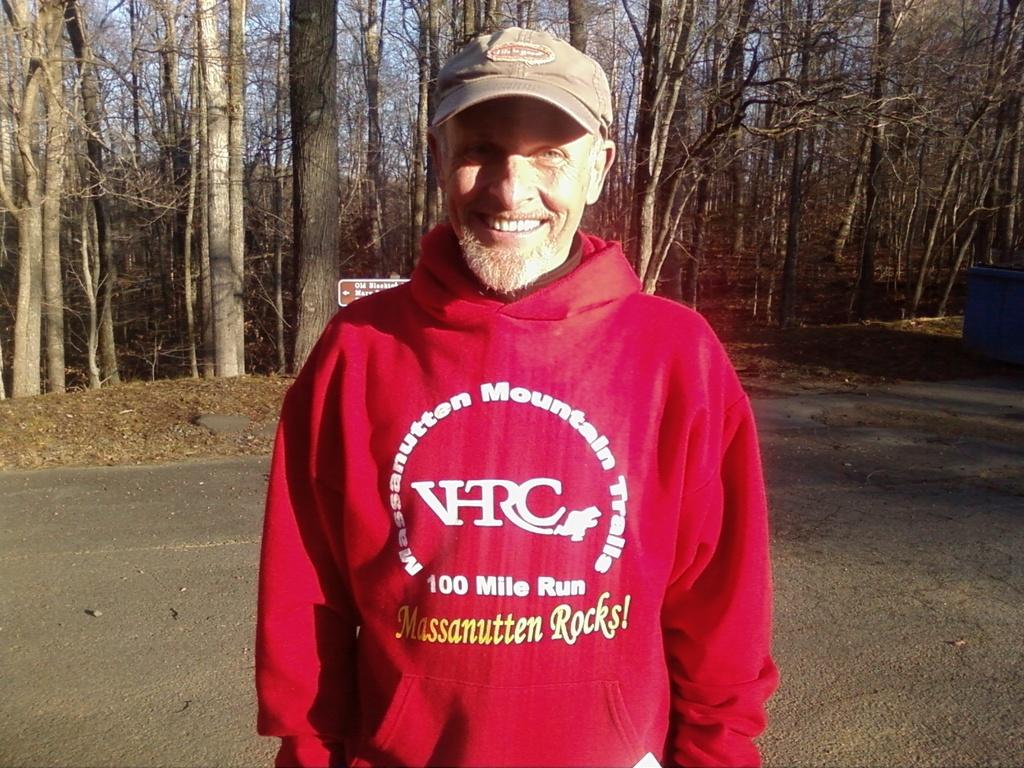What are the letters in the middle of his jacket?
Provide a succinct answer. Vhrc. Is that hoody for a 100 mile run?
Your answer should be very brief. Yes. 